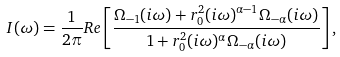<formula> <loc_0><loc_0><loc_500><loc_500>I ( \omega ) = \frac { 1 } { 2 \pi } R e \left [ \frac { \Omega _ { - 1 } ( i \omega ) + r _ { 0 } ^ { 2 } ( i \omega ) ^ { \alpha - 1 } \Omega _ { - \alpha } ( i \omega ) } { 1 + r _ { 0 } ^ { 2 } ( i \omega ) ^ { \alpha } \Omega _ { - \alpha } ( i \omega ) } \right ] ,</formula> 